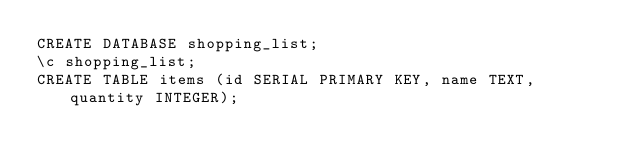Convert code to text. <code><loc_0><loc_0><loc_500><loc_500><_SQL_>CREATE DATABASE shopping_list;
\c shopping_list;
CREATE TABLE items (id SERIAL PRIMARY KEY, name TEXT, quantity INTEGER);
</code> 